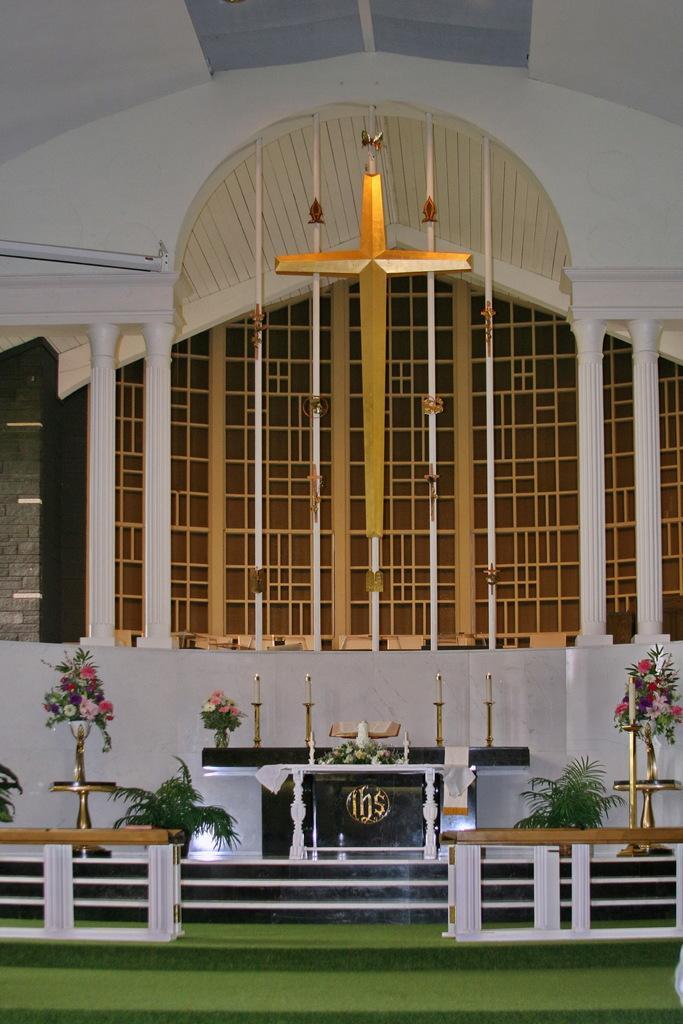Could you give a brief overview of what you see in this image? In this picture we can see a cross, pillars, flower vases on stands, candles and in the background we can see wall. 